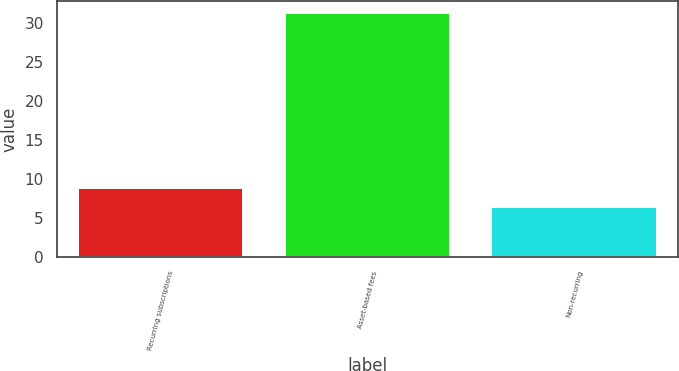<chart> <loc_0><loc_0><loc_500><loc_500><bar_chart><fcel>Recurring subscriptions<fcel>Asset-based fees<fcel>Non-recurring<nl><fcel>8.89<fcel>31.3<fcel>6.4<nl></chart> 